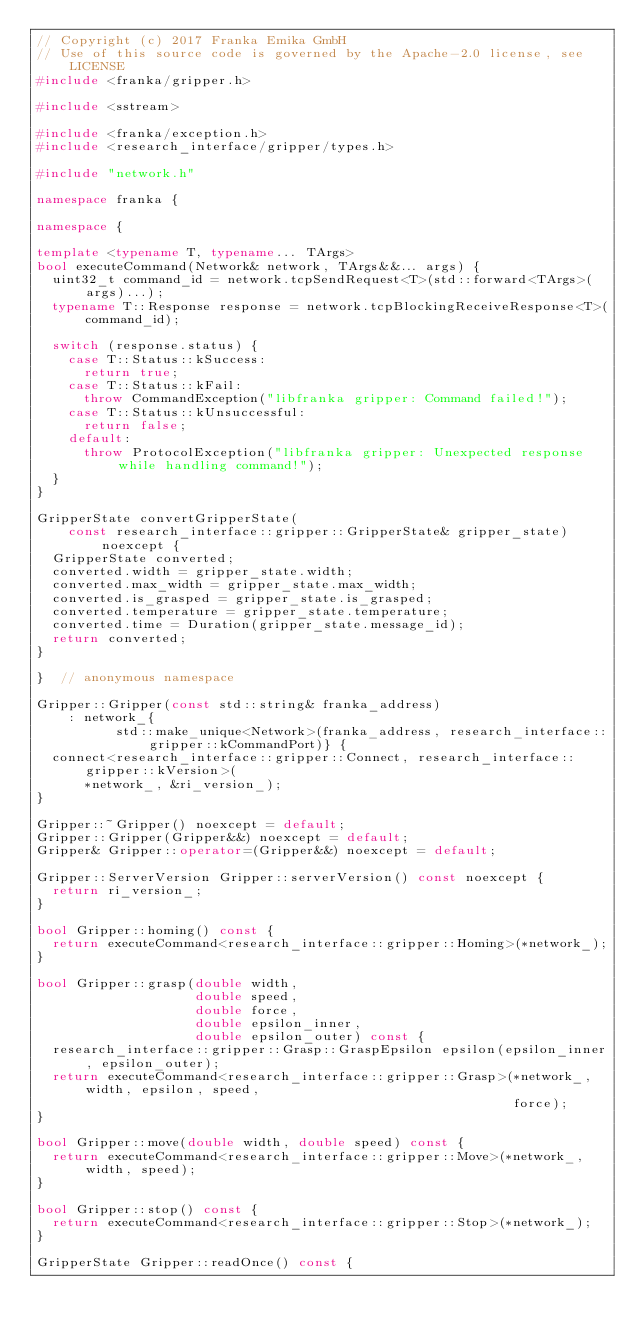Convert code to text. <code><loc_0><loc_0><loc_500><loc_500><_C++_>// Copyright (c) 2017 Franka Emika GmbH
// Use of this source code is governed by the Apache-2.0 license, see LICENSE
#include <franka/gripper.h>

#include <sstream>

#include <franka/exception.h>
#include <research_interface/gripper/types.h>

#include "network.h"

namespace franka {

namespace {

template <typename T, typename... TArgs>
bool executeCommand(Network& network, TArgs&&... args) {
  uint32_t command_id = network.tcpSendRequest<T>(std::forward<TArgs>(args)...);
  typename T::Response response = network.tcpBlockingReceiveResponse<T>(command_id);

  switch (response.status) {
    case T::Status::kSuccess:
      return true;
    case T::Status::kFail:
      throw CommandException("libfranka gripper: Command failed!");
    case T::Status::kUnsuccessful:
      return false;
    default:
      throw ProtocolException("libfranka gripper: Unexpected response while handling command!");
  }
}

GripperState convertGripperState(
    const research_interface::gripper::GripperState& gripper_state) noexcept {
  GripperState converted;
  converted.width = gripper_state.width;
  converted.max_width = gripper_state.max_width;
  converted.is_grasped = gripper_state.is_grasped;
  converted.temperature = gripper_state.temperature;
  converted.time = Duration(gripper_state.message_id);
  return converted;
}

}  // anonymous namespace

Gripper::Gripper(const std::string& franka_address)
    : network_{
          std::make_unique<Network>(franka_address, research_interface::gripper::kCommandPort)} {
  connect<research_interface::gripper::Connect, research_interface::gripper::kVersion>(
      *network_, &ri_version_);
}

Gripper::~Gripper() noexcept = default;
Gripper::Gripper(Gripper&&) noexcept = default;
Gripper& Gripper::operator=(Gripper&&) noexcept = default;

Gripper::ServerVersion Gripper::serverVersion() const noexcept {
  return ri_version_;
}

bool Gripper::homing() const {
  return executeCommand<research_interface::gripper::Homing>(*network_);
}

bool Gripper::grasp(double width,
                    double speed,
                    double force,
                    double epsilon_inner,
                    double epsilon_outer) const {
  research_interface::gripper::Grasp::GraspEpsilon epsilon(epsilon_inner, epsilon_outer);
  return executeCommand<research_interface::gripper::Grasp>(*network_, width, epsilon, speed,
                                                            force);
}

bool Gripper::move(double width, double speed) const {
  return executeCommand<research_interface::gripper::Move>(*network_, width, speed);
}

bool Gripper::stop() const {
  return executeCommand<research_interface::gripper::Stop>(*network_);
}

GripperState Gripper::readOnce() const {</code> 